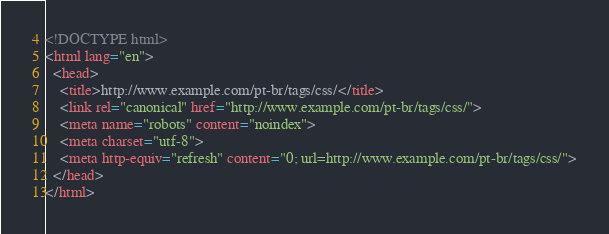<code> <loc_0><loc_0><loc_500><loc_500><_HTML_><!DOCTYPE html>
<html lang="en">
  <head>
    <title>http://www.example.com/pt-br/tags/css/</title>
    <link rel="canonical" href="http://www.example.com/pt-br/tags/css/">
    <meta name="robots" content="noindex">
    <meta charset="utf-8">
    <meta http-equiv="refresh" content="0; url=http://www.example.com/pt-br/tags/css/">
  </head>
</html>
</code> 